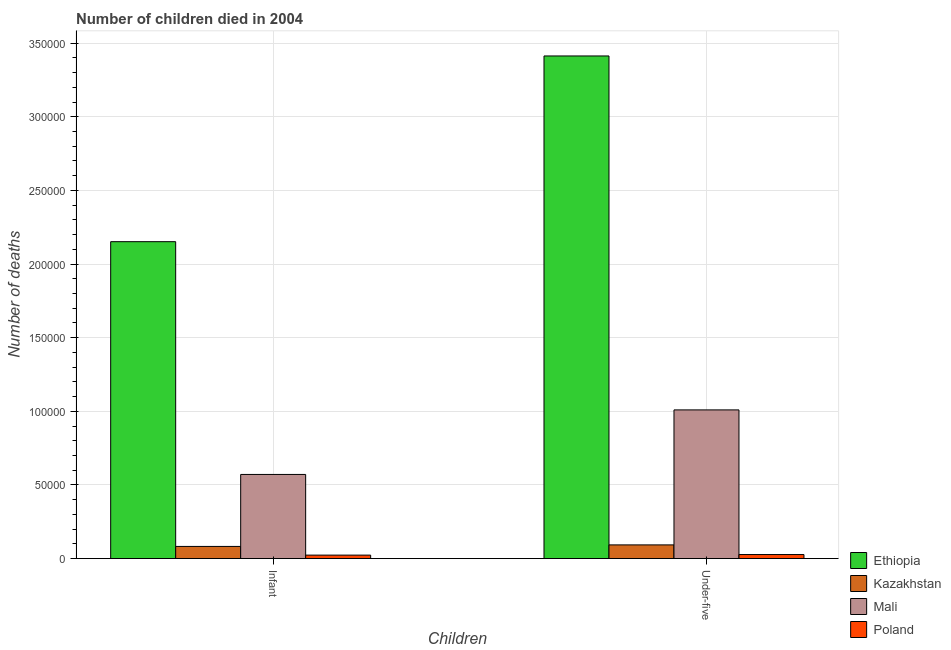How many different coloured bars are there?
Your answer should be compact. 4. How many groups of bars are there?
Your answer should be compact. 2. Are the number of bars per tick equal to the number of legend labels?
Give a very brief answer. Yes. Are the number of bars on each tick of the X-axis equal?
Offer a terse response. Yes. How many bars are there on the 2nd tick from the right?
Offer a terse response. 4. What is the label of the 1st group of bars from the left?
Keep it short and to the point. Infant. What is the number of under-five deaths in Kazakhstan?
Keep it short and to the point. 9285. Across all countries, what is the maximum number of infant deaths?
Offer a very short reply. 2.15e+05. Across all countries, what is the minimum number of under-five deaths?
Make the answer very short. 2741. In which country was the number of under-five deaths maximum?
Ensure brevity in your answer.  Ethiopia. What is the total number of infant deaths in the graph?
Your answer should be very brief. 2.83e+05. What is the difference between the number of infant deaths in Ethiopia and that in Poland?
Make the answer very short. 2.13e+05. What is the difference between the number of under-five deaths in Poland and the number of infant deaths in Ethiopia?
Offer a terse response. -2.12e+05. What is the average number of under-five deaths per country?
Provide a succinct answer. 1.14e+05. What is the difference between the number of under-five deaths and number of infant deaths in Ethiopia?
Give a very brief answer. 1.26e+05. What is the ratio of the number of infant deaths in Poland to that in Ethiopia?
Your answer should be very brief. 0.01. Is the number of under-five deaths in Kazakhstan less than that in Mali?
Ensure brevity in your answer.  Yes. What does the 3rd bar from the left in Infant represents?
Keep it short and to the point. Mali. What does the 4th bar from the right in Under-five represents?
Offer a very short reply. Ethiopia. What is the difference between two consecutive major ticks on the Y-axis?
Provide a succinct answer. 5.00e+04. Are the values on the major ticks of Y-axis written in scientific E-notation?
Ensure brevity in your answer.  No. How are the legend labels stacked?
Give a very brief answer. Vertical. What is the title of the graph?
Ensure brevity in your answer.  Number of children died in 2004. What is the label or title of the X-axis?
Offer a very short reply. Children. What is the label or title of the Y-axis?
Provide a succinct answer. Number of deaths. What is the Number of deaths in Ethiopia in Infant?
Make the answer very short. 2.15e+05. What is the Number of deaths in Kazakhstan in Infant?
Provide a succinct answer. 8239. What is the Number of deaths in Mali in Infant?
Provide a short and direct response. 5.71e+04. What is the Number of deaths of Poland in Infant?
Your answer should be very brief. 2348. What is the Number of deaths in Ethiopia in Under-five?
Provide a short and direct response. 3.41e+05. What is the Number of deaths in Kazakhstan in Under-five?
Provide a short and direct response. 9285. What is the Number of deaths of Mali in Under-five?
Give a very brief answer. 1.01e+05. What is the Number of deaths in Poland in Under-five?
Provide a short and direct response. 2741. Across all Children, what is the maximum Number of deaths in Ethiopia?
Offer a very short reply. 3.41e+05. Across all Children, what is the maximum Number of deaths of Kazakhstan?
Keep it short and to the point. 9285. Across all Children, what is the maximum Number of deaths in Mali?
Provide a succinct answer. 1.01e+05. Across all Children, what is the maximum Number of deaths in Poland?
Provide a short and direct response. 2741. Across all Children, what is the minimum Number of deaths in Ethiopia?
Provide a short and direct response. 2.15e+05. Across all Children, what is the minimum Number of deaths in Kazakhstan?
Make the answer very short. 8239. Across all Children, what is the minimum Number of deaths of Mali?
Ensure brevity in your answer.  5.71e+04. Across all Children, what is the minimum Number of deaths of Poland?
Provide a succinct answer. 2348. What is the total Number of deaths in Ethiopia in the graph?
Keep it short and to the point. 5.56e+05. What is the total Number of deaths of Kazakhstan in the graph?
Make the answer very short. 1.75e+04. What is the total Number of deaths in Mali in the graph?
Offer a very short reply. 1.58e+05. What is the total Number of deaths of Poland in the graph?
Give a very brief answer. 5089. What is the difference between the Number of deaths in Ethiopia in Infant and that in Under-five?
Your answer should be very brief. -1.26e+05. What is the difference between the Number of deaths in Kazakhstan in Infant and that in Under-five?
Ensure brevity in your answer.  -1046. What is the difference between the Number of deaths of Mali in Infant and that in Under-five?
Your response must be concise. -4.38e+04. What is the difference between the Number of deaths of Poland in Infant and that in Under-five?
Provide a short and direct response. -393. What is the difference between the Number of deaths in Ethiopia in Infant and the Number of deaths in Kazakhstan in Under-five?
Your answer should be compact. 2.06e+05. What is the difference between the Number of deaths in Ethiopia in Infant and the Number of deaths in Mali in Under-five?
Give a very brief answer. 1.14e+05. What is the difference between the Number of deaths in Ethiopia in Infant and the Number of deaths in Poland in Under-five?
Offer a very short reply. 2.12e+05. What is the difference between the Number of deaths in Kazakhstan in Infant and the Number of deaths in Mali in Under-five?
Ensure brevity in your answer.  -9.27e+04. What is the difference between the Number of deaths in Kazakhstan in Infant and the Number of deaths in Poland in Under-five?
Give a very brief answer. 5498. What is the difference between the Number of deaths of Mali in Infant and the Number of deaths of Poland in Under-five?
Your answer should be very brief. 5.44e+04. What is the average Number of deaths in Ethiopia per Children?
Your response must be concise. 2.78e+05. What is the average Number of deaths in Kazakhstan per Children?
Your answer should be compact. 8762. What is the average Number of deaths in Mali per Children?
Ensure brevity in your answer.  7.90e+04. What is the average Number of deaths of Poland per Children?
Keep it short and to the point. 2544.5. What is the difference between the Number of deaths in Ethiopia and Number of deaths in Kazakhstan in Infant?
Offer a terse response. 2.07e+05. What is the difference between the Number of deaths in Ethiopia and Number of deaths in Mali in Infant?
Give a very brief answer. 1.58e+05. What is the difference between the Number of deaths in Ethiopia and Number of deaths in Poland in Infant?
Your answer should be very brief. 2.13e+05. What is the difference between the Number of deaths in Kazakhstan and Number of deaths in Mali in Infant?
Give a very brief answer. -4.89e+04. What is the difference between the Number of deaths in Kazakhstan and Number of deaths in Poland in Infant?
Make the answer very short. 5891. What is the difference between the Number of deaths in Mali and Number of deaths in Poland in Infant?
Your answer should be very brief. 5.48e+04. What is the difference between the Number of deaths in Ethiopia and Number of deaths in Kazakhstan in Under-five?
Make the answer very short. 3.32e+05. What is the difference between the Number of deaths of Ethiopia and Number of deaths of Mali in Under-five?
Keep it short and to the point. 2.40e+05. What is the difference between the Number of deaths of Ethiopia and Number of deaths of Poland in Under-five?
Your response must be concise. 3.39e+05. What is the difference between the Number of deaths of Kazakhstan and Number of deaths of Mali in Under-five?
Provide a short and direct response. -9.17e+04. What is the difference between the Number of deaths in Kazakhstan and Number of deaths in Poland in Under-five?
Ensure brevity in your answer.  6544. What is the difference between the Number of deaths of Mali and Number of deaths of Poland in Under-five?
Provide a short and direct response. 9.82e+04. What is the ratio of the Number of deaths of Ethiopia in Infant to that in Under-five?
Your answer should be very brief. 0.63. What is the ratio of the Number of deaths of Kazakhstan in Infant to that in Under-five?
Provide a short and direct response. 0.89. What is the ratio of the Number of deaths in Mali in Infant to that in Under-five?
Offer a terse response. 0.57. What is the ratio of the Number of deaths of Poland in Infant to that in Under-five?
Keep it short and to the point. 0.86. What is the difference between the highest and the second highest Number of deaths of Ethiopia?
Offer a very short reply. 1.26e+05. What is the difference between the highest and the second highest Number of deaths in Kazakhstan?
Ensure brevity in your answer.  1046. What is the difference between the highest and the second highest Number of deaths in Mali?
Provide a succinct answer. 4.38e+04. What is the difference between the highest and the second highest Number of deaths in Poland?
Give a very brief answer. 393. What is the difference between the highest and the lowest Number of deaths in Ethiopia?
Your answer should be very brief. 1.26e+05. What is the difference between the highest and the lowest Number of deaths in Kazakhstan?
Your response must be concise. 1046. What is the difference between the highest and the lowest Number of deaths in Mali?
Give a very brief answer. 4.38e+04. What is the difference between the highest and the lowest Number of deaths of Poland?
Your response must be concise. 393. 